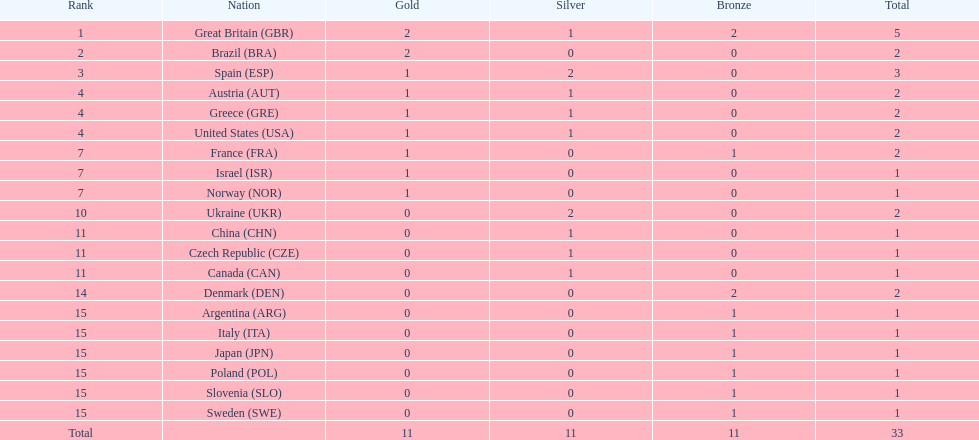How many medals in total has the united states achieved? 2. 